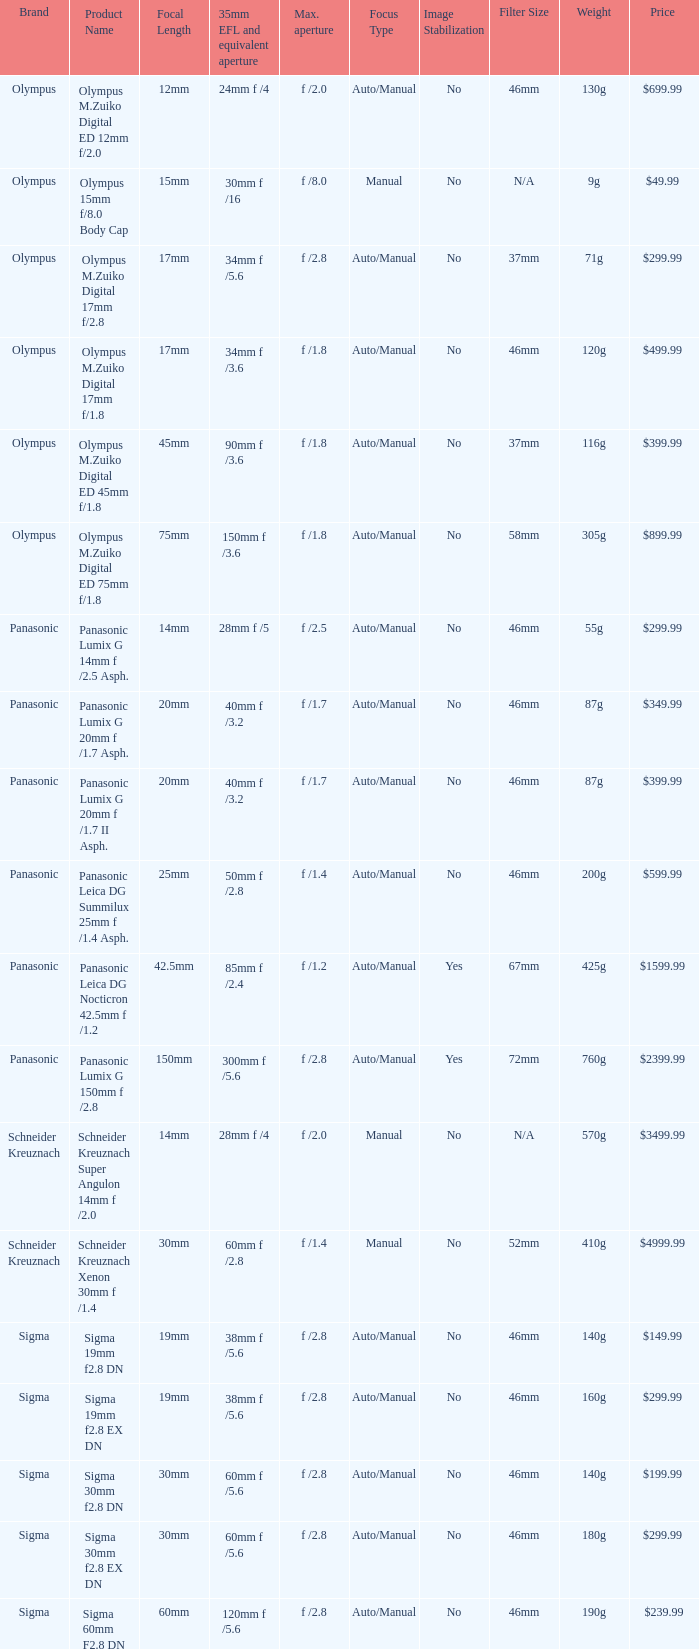What is the maximum aperture of the lens(es) with a focal length of 20mm? F /1.7, f /1.7. 